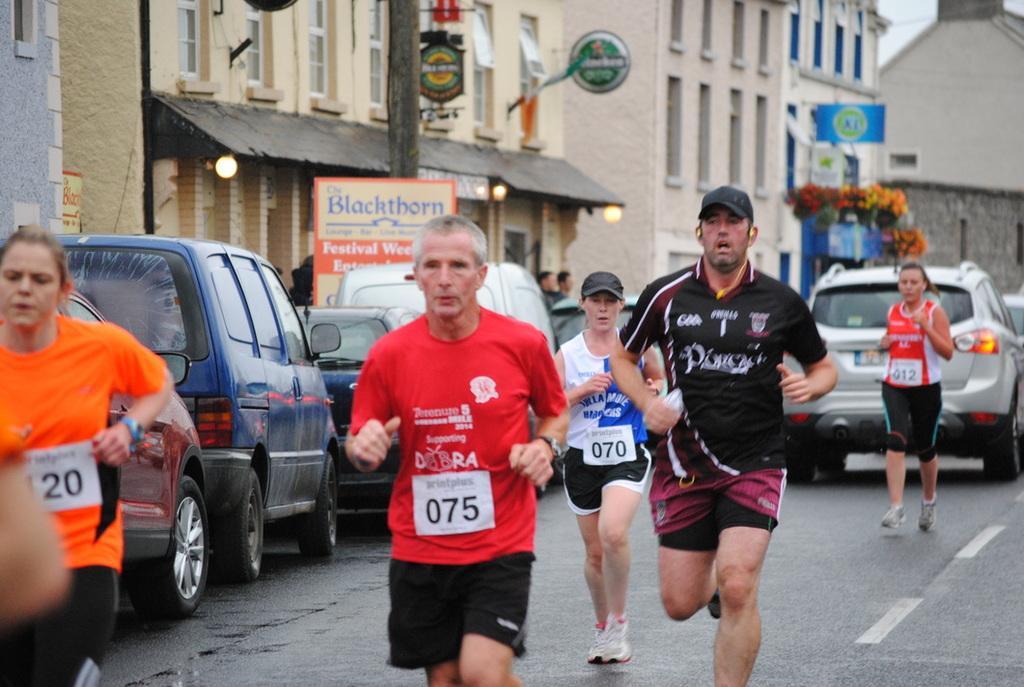How would you summarize this image in a sentence or two? In this image there are people running on the road. Beside them there are cars parked on the road. Behind the cars there are buildings. There are boards with text on the buildings. In front of the buildings there are poles and boards on the walkway. 